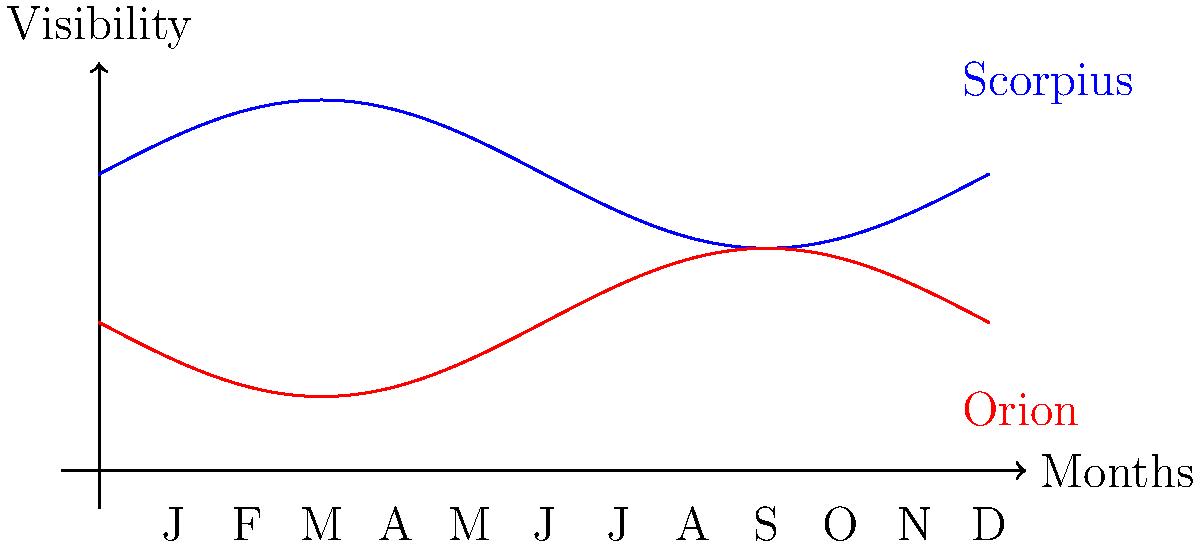Based on the graph showing the visibility of constellations throughout the year from Leblon's latitude (approximately 23°S), during which month is Scorpius most visible in the night sky? To determine when Scorpius is most visible from Leblon, we need to analyze the graph:

1. The blue curve represents Scorpius' visibility throughout the year.
2. The x-axis shows the months (J for January through D for December).
3. The y-axis represents visibility, with higher values indicating better visibility.
4. Scorpius' visibility follows a sinusoidal pattern, peaking once during the year.
5. The highest point of the blue curve occurs around the middle of the year.
6. Counting the months, we can see that the peak is closest to the "J" label in the middle, which represents June.

Therefore, Scorpius is most visible from Leblon in June, which coincides with the Southern Hemisphere's winter when Scorpius is high in the night sky.
Answer: June 